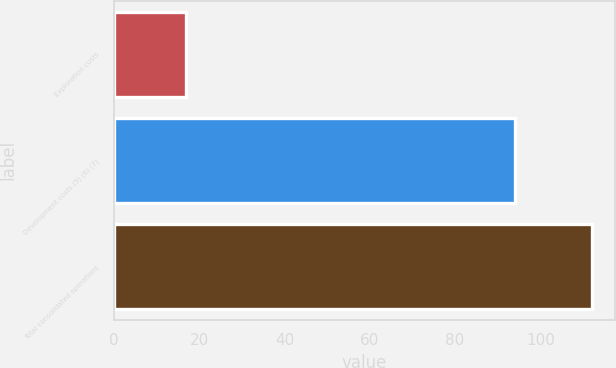<chart> <loc_0><loc_0><loc_500><loc_500><bar_chart><fcel>Exploration costs<fcel>Development costs (5) (6) (7)<fcel>Total consolidated operations<nl><fcel>17<fcel>94<fcel>112<nl></chart> 